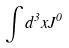Convert formula to latex. <formula><loc_0><loc_0><loc_500><loc_500>\int d ^ { 3 } x J ^ { 0 }</formula> 